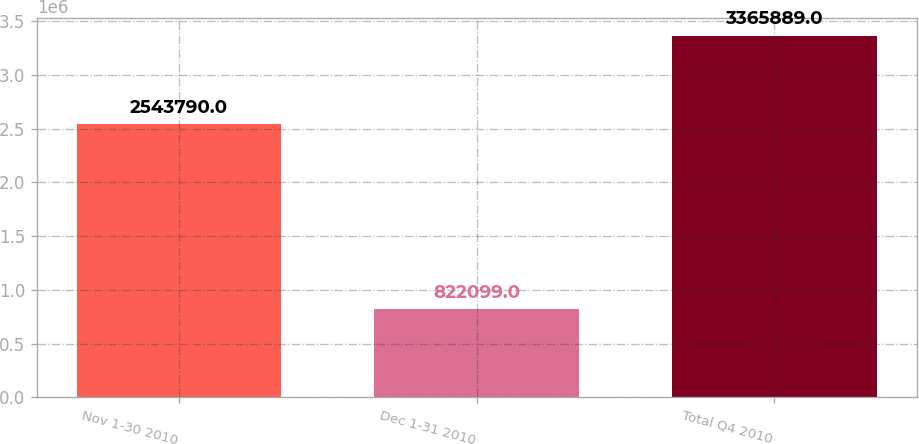Convert chart. <chart><loc_0><loc_0><loc_500><loc_500><bar_chart><fcel>Nov 1-30 2010<fcel>Dec 1-31 2010<fcel>Total Q4 2010<nl><fcel>2.54379e+06<fcel>822099<fcel>3.36589e+06<nl></chart> 